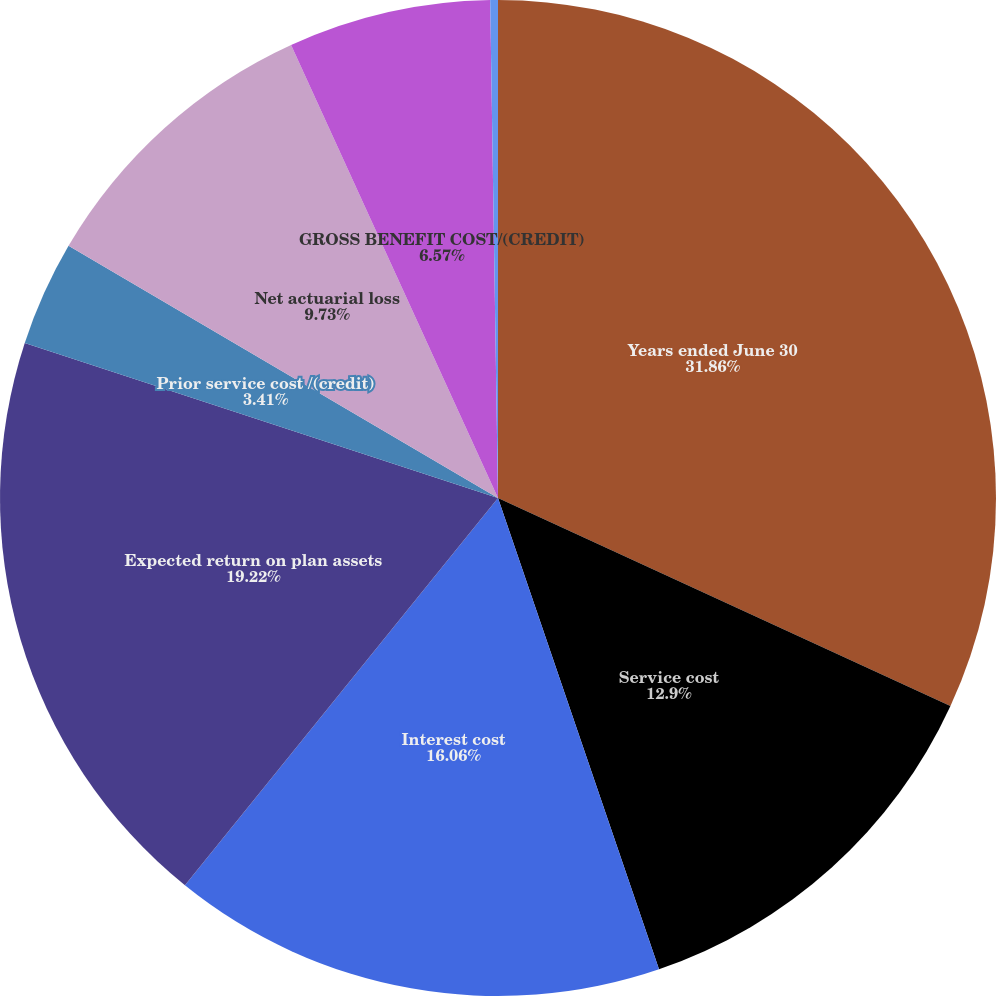<chart> <loc_0><loc_0><loc_500><loc_500><pie_chart><fcel>Years ended June 30<fcel>Service cost<fcel>Interest cost<fcel>Expected return on plan assets<fcel>Prior service cost /(credit)<fcel>Net actuarial loss<fcel>GROSS BENEFIT COST/(CREDIT)<fcel>NET PERIODIC BENEFIT<nl><fcel>31.86%<fcel>12.9%<fcel>16.06%<fcel>19.22%<fcel>3.41%<fcel>9.73%<fcel>6.57%<fcel>0.25%<nl></chart> 